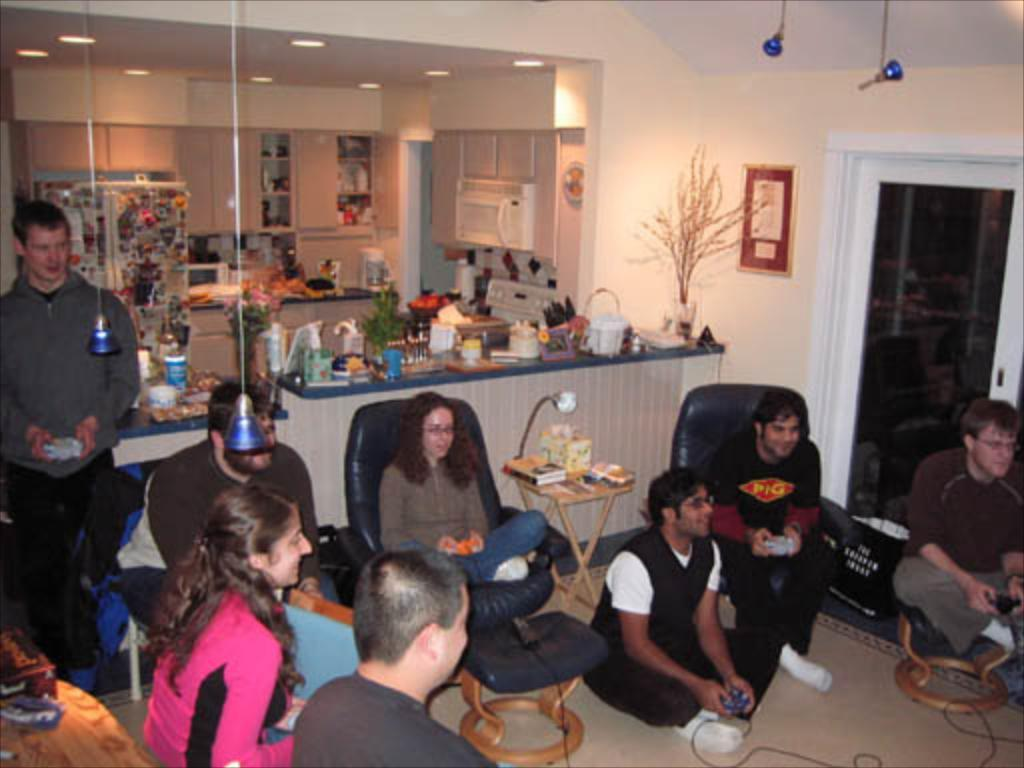What are the people in the image doing? The people in the image are sitting. Can you describe what is visible in the background of the image? Unfortunately, the provided facts do not give enough information to describe the background of the image. How many kites can be seen flying in the image? There is no mention of kites in the provided facts, so we cannot determine if any kites are present in the image. 